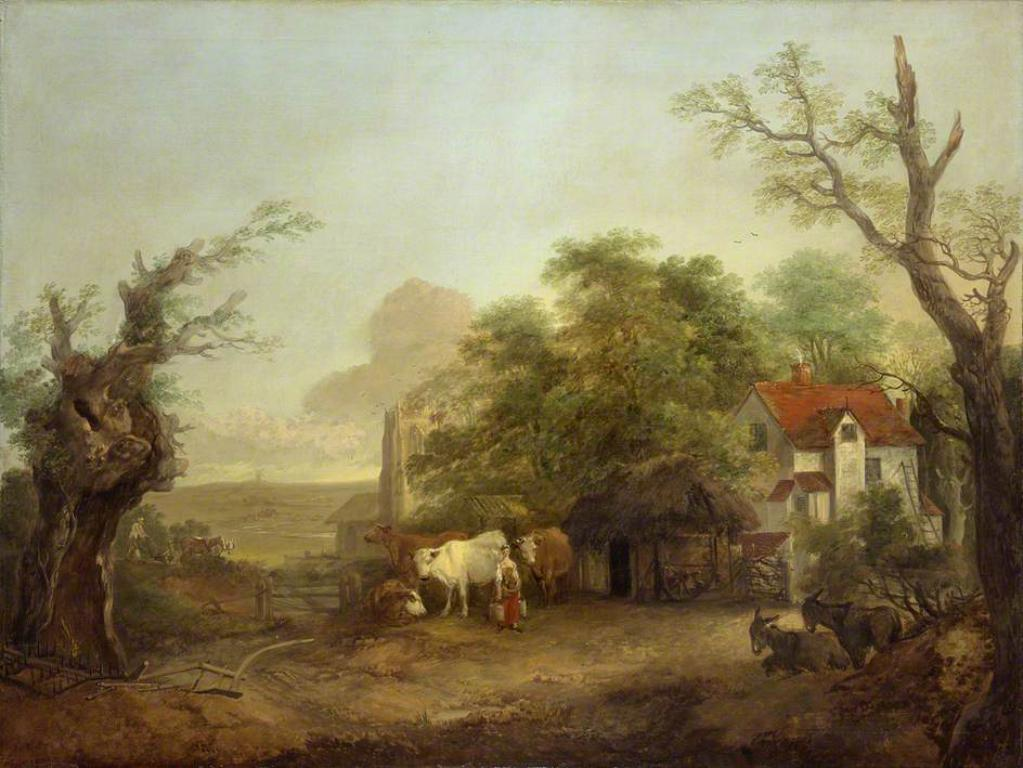What types of structures are depicted in the painting? The painting contains buildings. What natural elements are present in the painting? The painting contains trees. What type of animals can be seen in the painting? The painting contains cattle. Are there any human figures in the painting? Yes, the painting contains a person. How many chairs are visible in the painting? There are no chairs present in the painting. What type of footwear is the person wearing in the painting? There is no information about the person's footwear in the painting. 